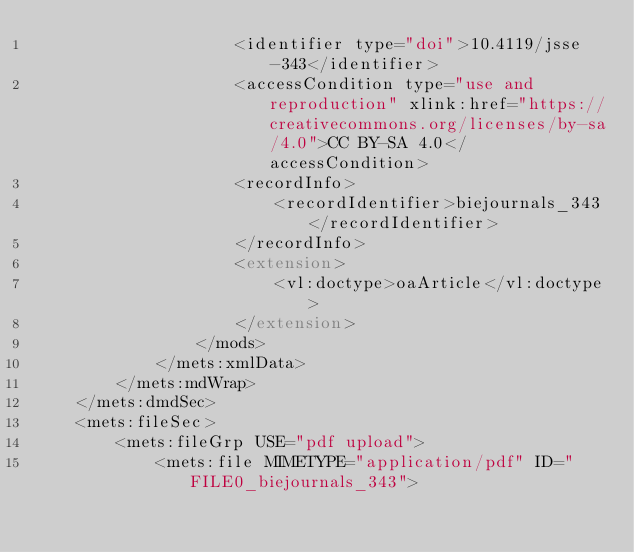<code> <loc_0><loc_0><loc_500><loc_500><_XML_>                    <identifier type="doi">10.4119/jsse-343</identifier>
                    <accessCondition type="use and reproduction" xlink:href="https://creativecommons.org/licenses/by-sa/4.0">CC BY-SA 4.0</accessCondition>
                    <recordInfo>
                        <recordIdentifier>biejournals_343</recordIdentifier>
                    </recordInfo>
                    <extension>
                        <vl:doctype>oaArticle</vl:doctype>
                    </extension>
                </mods>
            </mets:xmlData>
        </mets:mdWrap>
    </mets:dmdSec>
    <mets:fileSec>
        <mets:fileGrp USE="pdf upload">
            <mets:file MIMETYPE="application/pdf" ID="FILE0_biejournals_343"></code> 